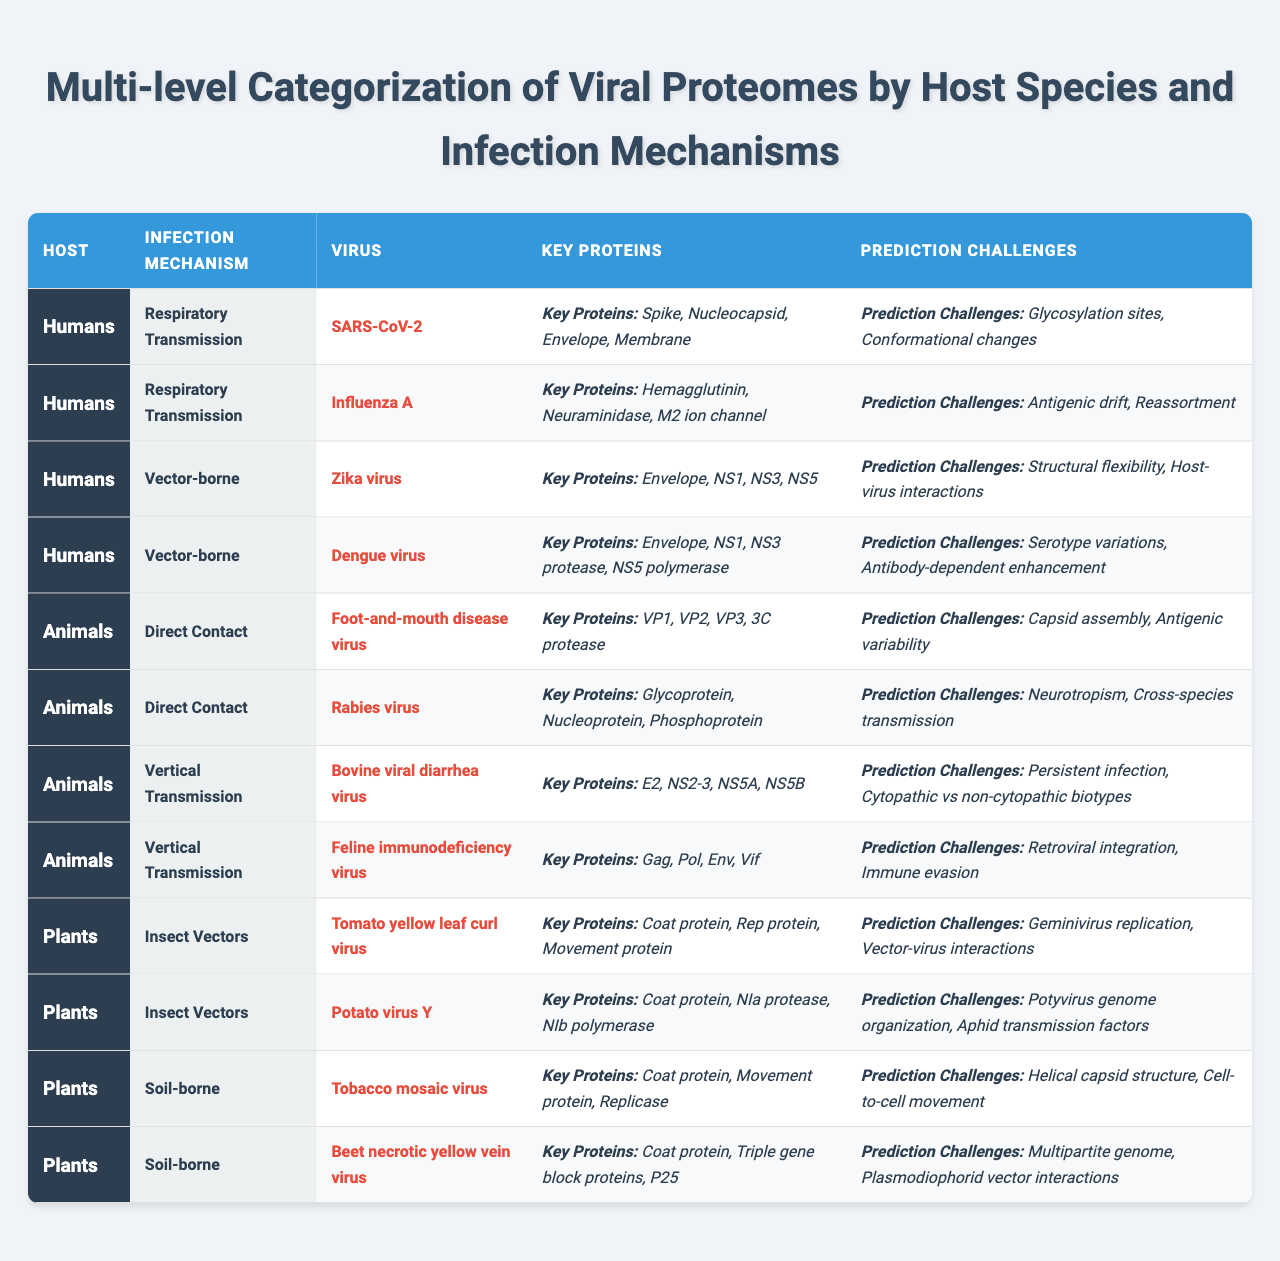What viruses are transmitted through respiratory mechanisms in humans? The table lists "SARS-CoV-2" and "Influenza A" under the respiratory transmission mechanism for humans.
Answer: SARS-CoV-2, Influenza A Which key protein is common among the viruses transmitted by direct contact in animals? Both "Foot-and-mouth disease virus" and "Rabies virus" share the key protein "Glycoprotein."
Answer: None (they don't share a common key protein) How many viruses are associated with vector-borne infection mechanisms in humans? There are two vector-borne viruses listed: "Zika virus" and "Dengue virus." Hence, the count is 2.
Answer: 2 Does the "Dengue virus" face challenges due to serotype variations? The table mentions that "Serotype variations" is a prediction challenge for "Dengue virus." Therefore, the answer is yes.
Answer: Yes What is the total number of key proteins listed for the "SARS-CoV-2"? The key proteins for "SARS-CoV-2" are listed as "Spike, Nucleocapsid, Envelope, Membrane," totaling four key proteins.
Answer: 4 Are the key proteins of "Feline immunodeficiency virus" related to immune evasion? The "Feline immunodeficiency virus" has "Immune evasion" listed as a prediction challenge, thus confirming its relevance to immune evasion.
Answer: Yes Which host species has the highest number of distinct infection mechanisms listed? The table includes three hosts: Humans (2 mechanisms), Animals (2 mechanisms), and Plants (2 mechanisms), indicating they all have an equal number.
Answer: None (they are equal) What are the prediction challenges listed for the "Zika virus"? The prediction challenges for the "Zika virus" are "Structural flexibility" and "Host-virus interactions."
Answer: Structural flexibility, Host-virus interactions Which virus has the most key proteins listed in the table? By comparing the key proteins across all listed viruses, "Rabies virus" has three key proteins whereas others have either three or four; thus, "Rabies virus" does not have the most.
Answer: None (No clear winner) Identify the unique key protein of "Potato virus Y"? The unique key proteins for "Potato virus Y" are "Coat protein," "NIa protease," and "NIb polymerase," indicating these are specific to it.
Answer: None (No unique, it's shared) 